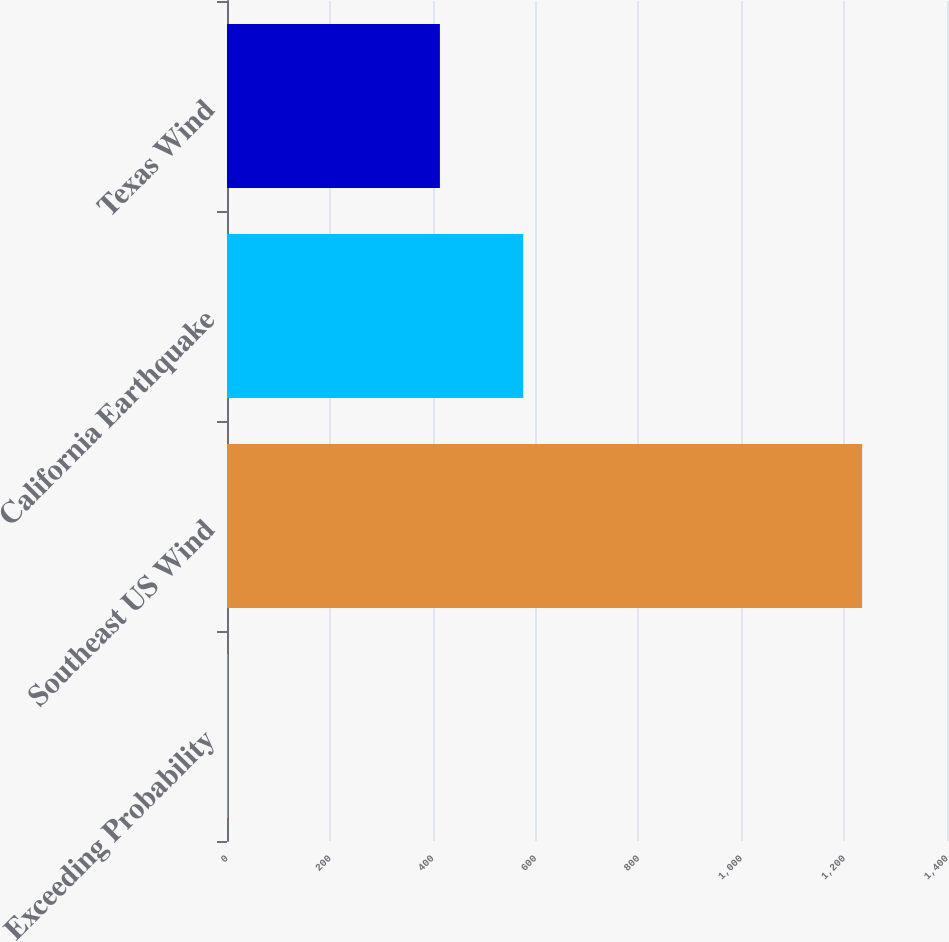<chart> <loc_0><loc_0><loc_500><loc_500><bar_chart><fcel>Exceeding Probability<fcel>Southeast US Wind<fcel>California Earthquake<fcel>Texas Wind<nl><fcel>2<fcel>1235<fcel>576<fcel>414<nl></chart> 